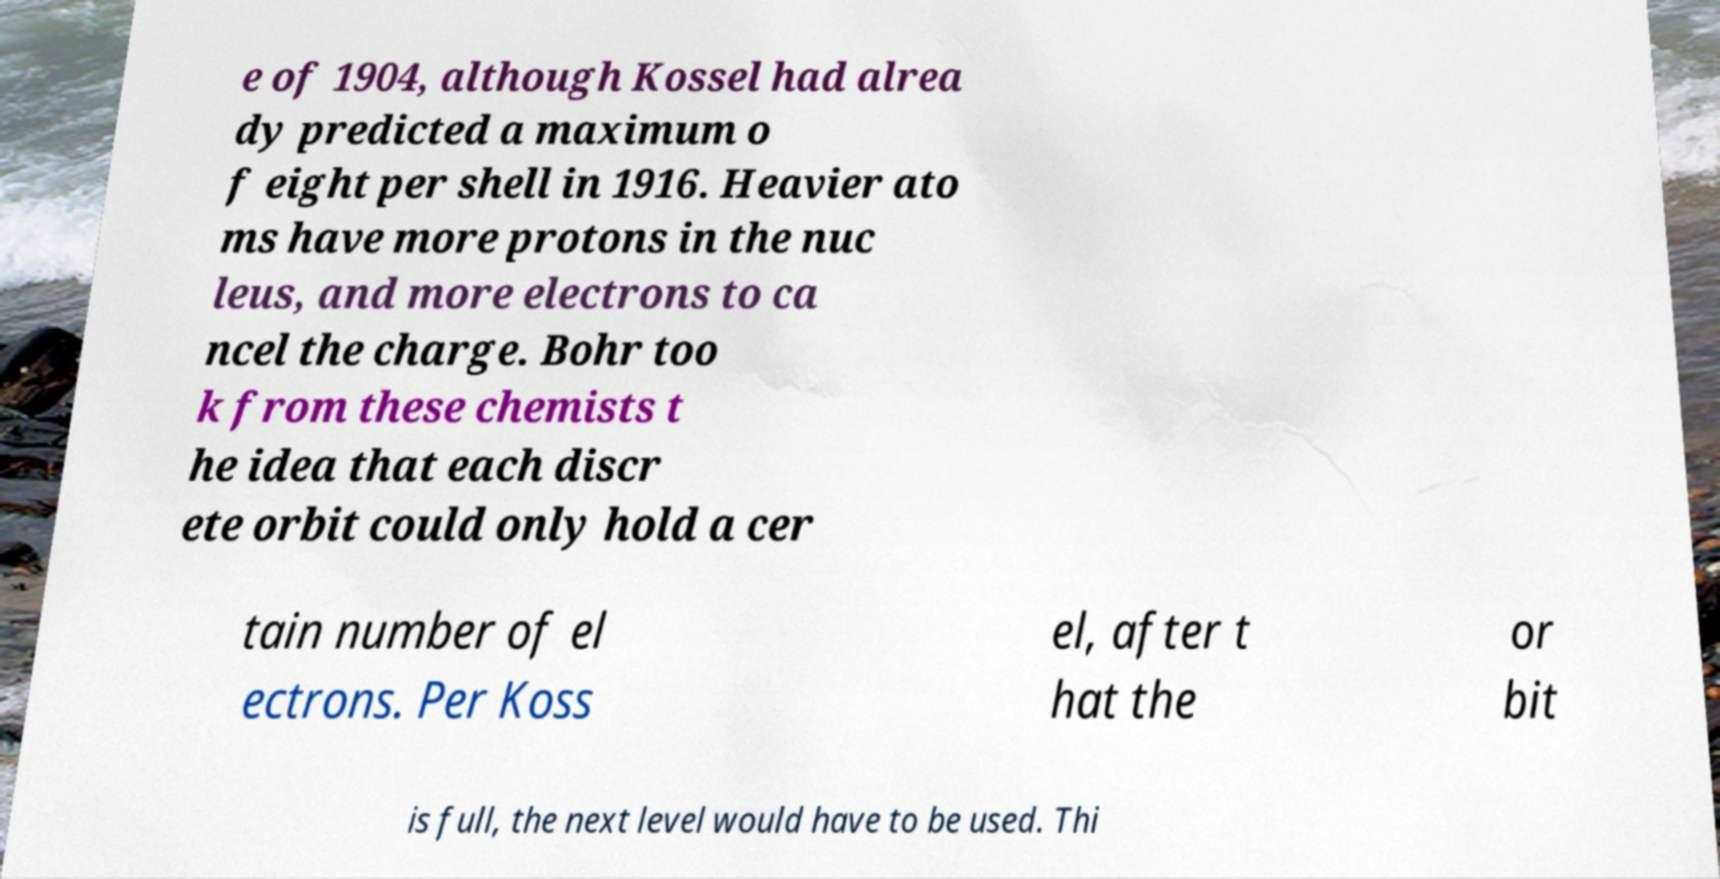Please read and relay the text visible in this image. What does it say? e of 1904, although Kossel had alrea dy predicted a maximum o f eight per shell in 1916. Heavier ato ms have more protons in the nuc leus, and more electrons to ca ncel the charge. Bohr too k from these chemists t he idea that each discr ete orbit could only hold a cer tain number of el ectrons. Per Koss el, after t hat the or bit is full, the next level would have to be used. Thi 